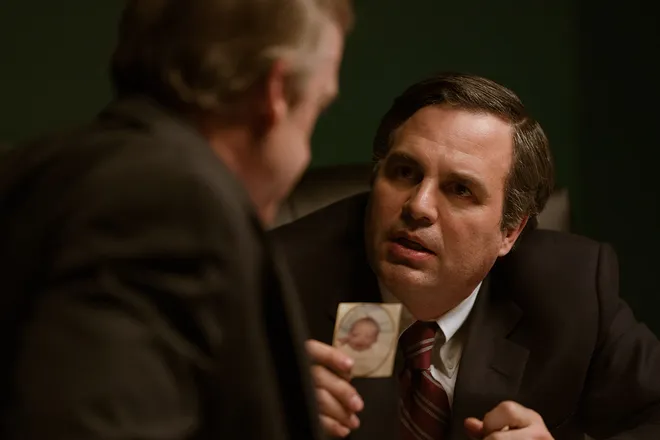What do you think the man in the dark suit with the photograph is thinking about? The man holding the photograph appears to be deeply contemplative. His posture and the intensity in his gaze might suggest that he's weighing the gravity of the situation being discussed. Given that he's holding a photograph, it could be personal and emotionally charged, possibly involving a loved one or a significant memory. Do you think this could be a courtroom setting? What details support or contradict this idea? This setting could indeed be interpreted as a courtroom or a legal office due to the formal attire of the characters and the serious expressions on their faces. The dim lighting and the intense conversation might also support this idea, as these scenes are often depicted in legal dramas. However, the background lacks clear courtroom identifiers such as a judge's bench, flags, or juror seating which leaves room for other interpretations like a private office meeting. 